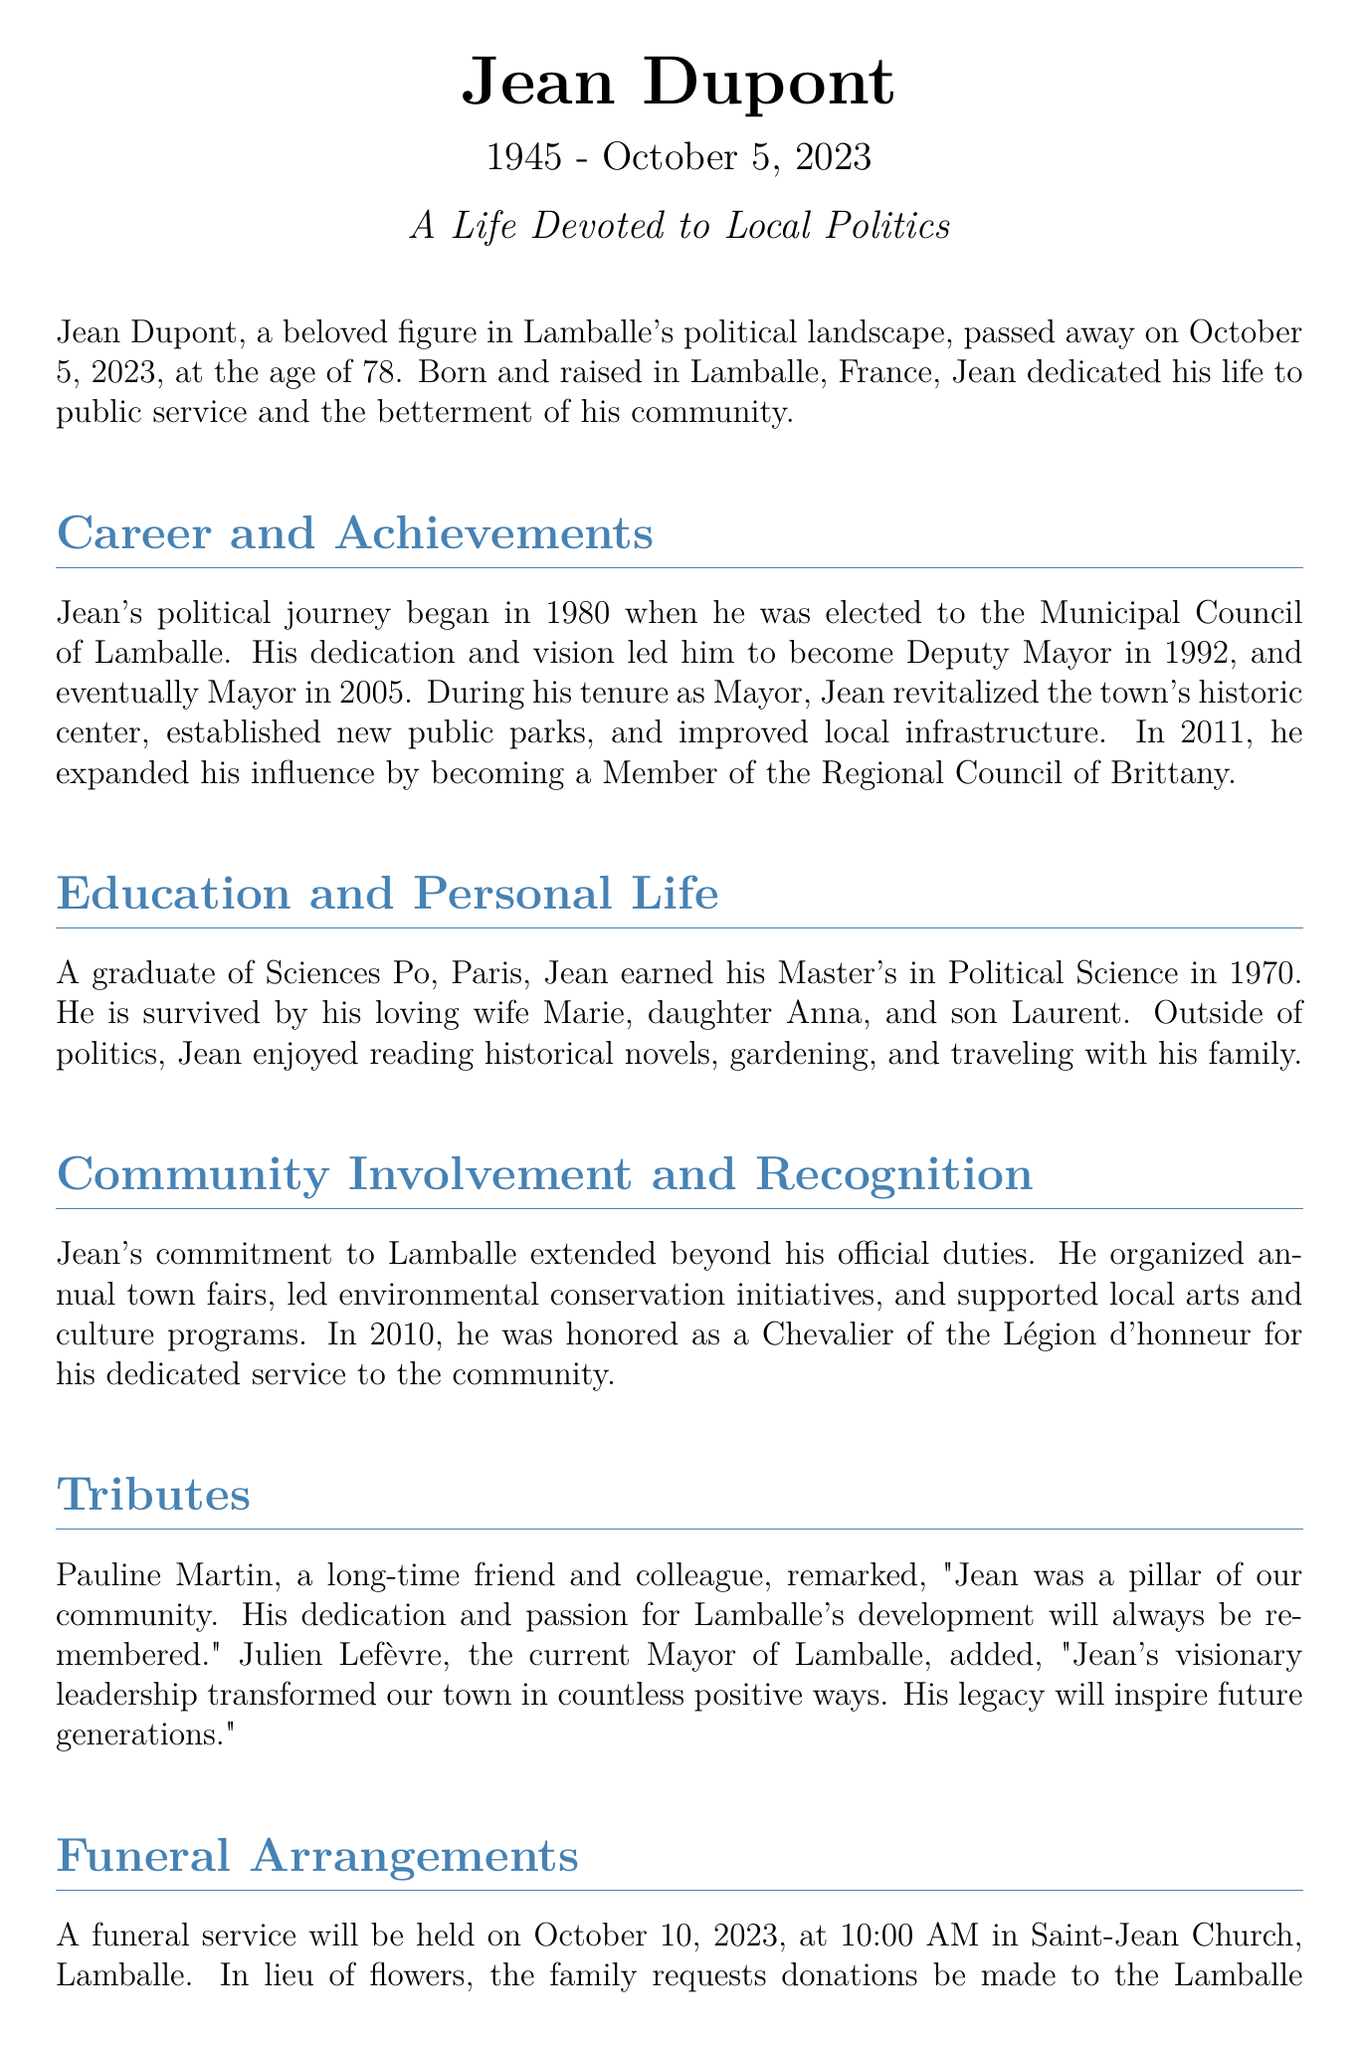What was Jean Dupont's age at the time of his passing? Jean Dupont passed away at the age of 78, as stated in the document.
Answer: 78 In what year was Jean Dupont elected to the Municipal Council of Lamballe? The document mentions that Jean's political journey began in 1980 when he was elected to the Municipal Council.
Answer: 1980 Who is Jean Dupont survived by? The document lists his loving wife Marie, daughter Anna, and son Laurent as his survivors.
Answer: Marie, Anna, Laurent What honor did Jean Dupont receive in 2010? The document states that he was honored as a Chevalier of the Légion d'honneur for his dedicated service.
Answer: Chevalier of the Légion d'honneur When is the funeral service for Jean Dupont scheduled? According to the document, the funeral service is scheduled for October 10, 2023.
Answer: October 10, 2023 What was one of Jean Dupont's hobbies mentioned in the document? The obituary highlights that he enjoyed gardening among other activities.
Answer: Gardening How did Julien Lefèvre describe Jean Dupont's leadership? Julien Lefèvre mentioned that Jean's visionary leadership transformed their town in countless positive ways.
Answer: Visionary leadership What was a significant initiative Jean Dupont led during his political career? The document notes that he led environmental conservation initiatives as part of his community involvement.
Answer: Environmental conservation initiatives 